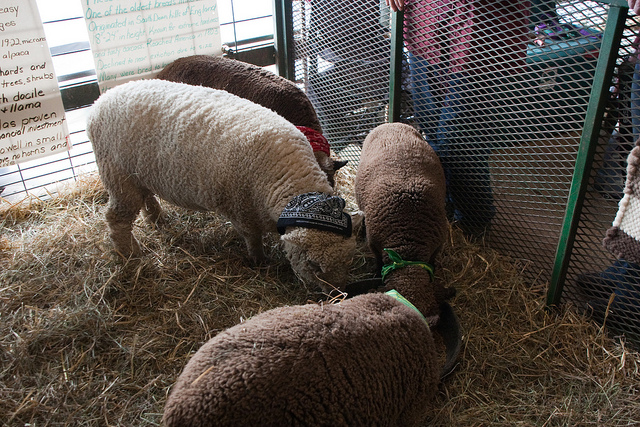Identify the text contained in this image. docile proven well in small and wellon proven ancial os lloma h strubs trees and honds alpaon 1922 easy 